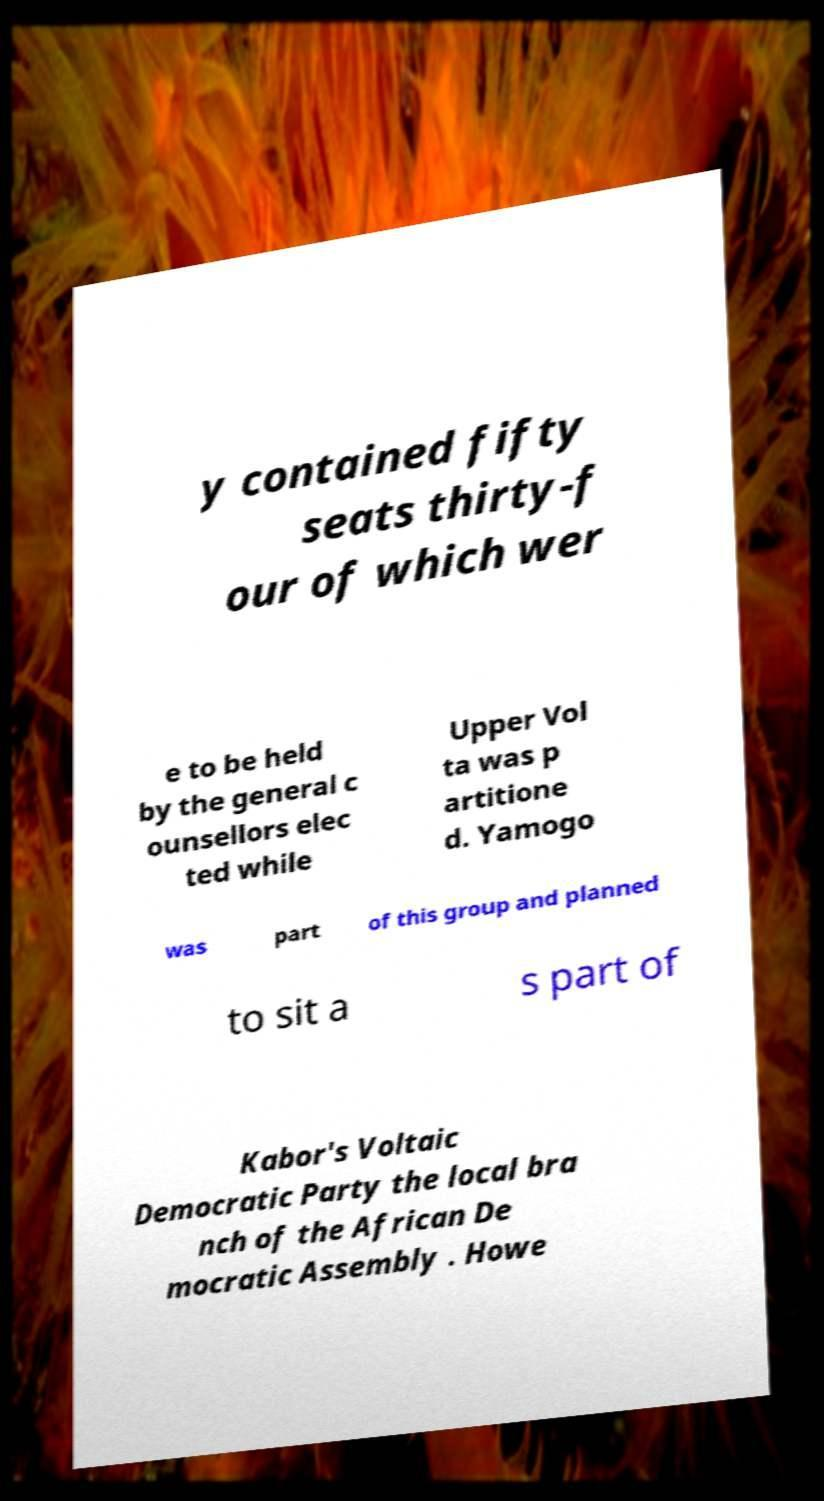Please read and relay the text visible in this image. What does it say? y contained fifty seats thirty-f our of which wer e to be held by the general c ounsellors elec ted while Upper Vol ta was p artitione d. Yamogo was part of this group and planned to sit a s part of Kabor's Voltaic Democratic Party the local bra nch of the African De mocratic Assembly . Howe 